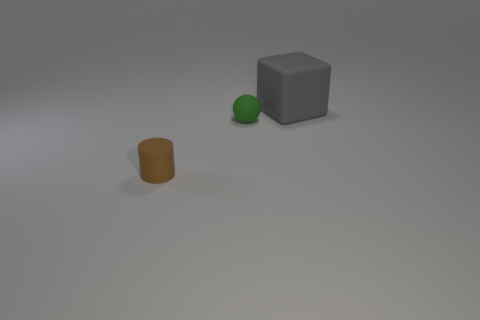There is a object that is in front of the small green thing; what is its size?
Your response must be concise. Small. Do the large gray thing and the small object that is on the left side of the green matte thing have the same material?
Ensure brevity in your answer.  Yes. What number of gray matte cubes are in front of the object behind the tiny thing that is behind the small brown rubber cylinder?
Your response must be concise. 0. What number of yellow things are either tiny things or large things?
Your answer should be compact. 0. What shape is the small rubber thing on the right side of the brown matte object?
Make the answer very short. Sphere. There is a matte ball that is the same size as the brown cylinder; what is its color?
Ensure brevity in your answer.  Green. There is a green matte object; does it have the same shape as the small thing that is in front of the small sphere?
Your answer should be very brief. No. What material is the thing right of the small rubber object that is behind the matte thing that is in front of the green ball?
Your answer should be compact. Rubber. What number of small things are either green spheres or brown things?
Offer a terse response. 2. What number of other objects are there of the same size as the ball?
Keep it short and to the point. 1. 